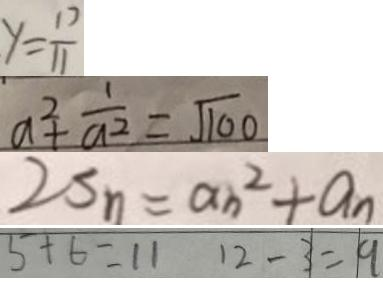<formula> <loc_0><loc_0><loc_500><loc_500>y = \frac { 1 7 } { 1 1 } 
 a ^ { 2 } + \frac { 1 } { a ^ { 2 } } = \sqrt { 1 0 0 } 
 2 S _ { n } = a _ { n } ^ { 2 } + a _ { n } 
 5 + 6 = 1 1 1 2 - 3 = 9</formula> 